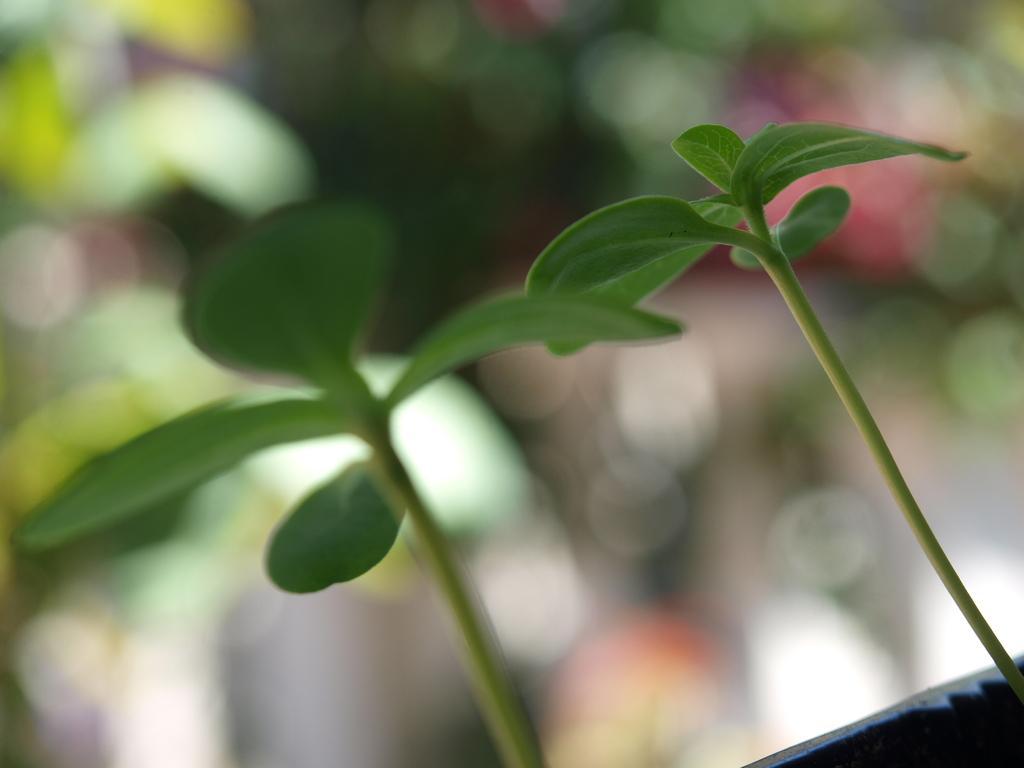Please provide a concise description of this image. In this picture we can see the two plants with the green leaves. The background of the image is very blurry. 